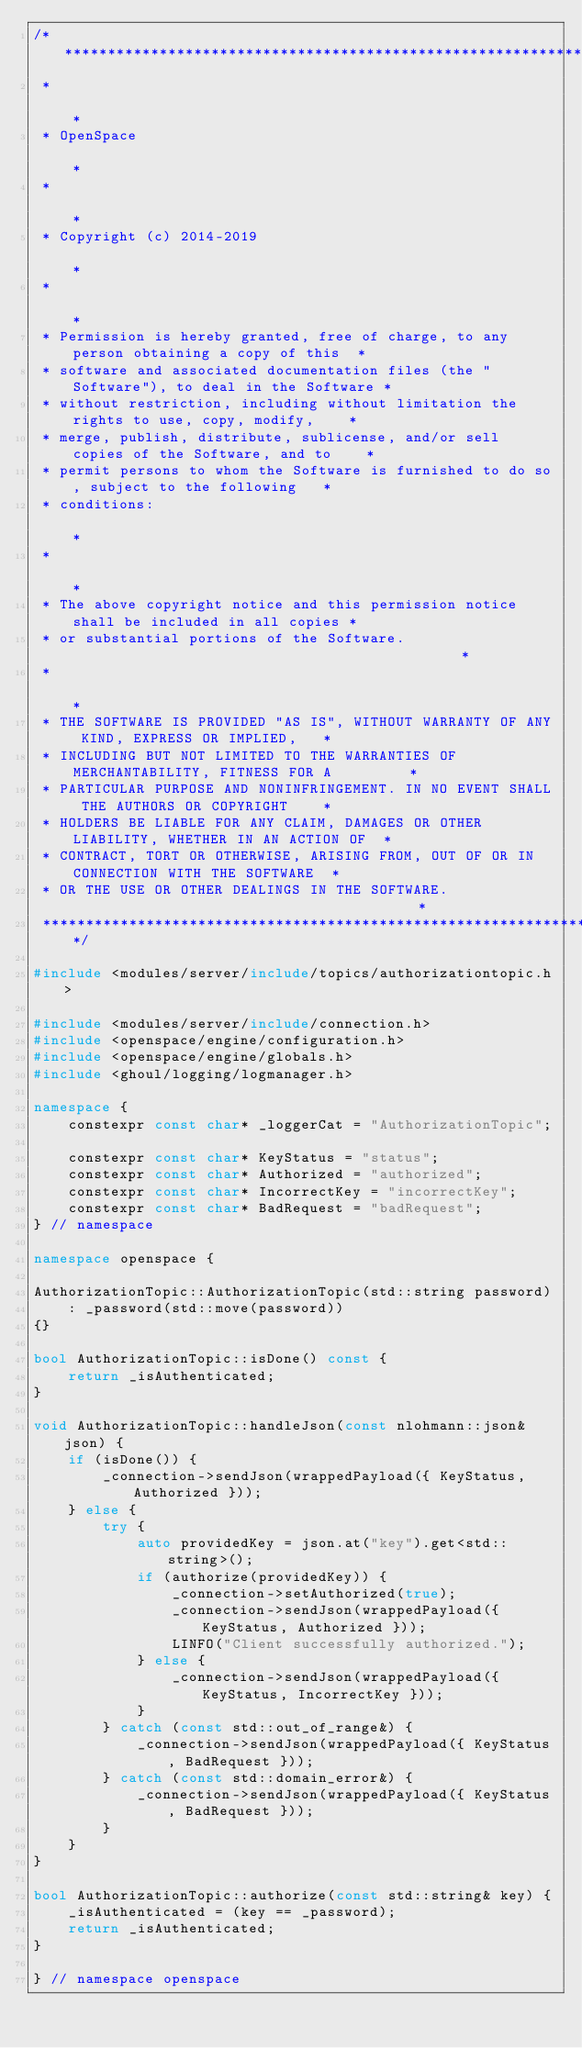Convert code to text. <code><loc_0><loc_0><loc_500><loc_500><_C++_>/*****************************************************************************************
 *                                                                                       *
 * OpenSpace                                                                             *
 *                                                                                       *
 * Copyright (c) 2014-2019                                                               *
 *                                                                                       *
 * Permission is hereby granted, free of charge, to any person obtaining a copy of this  *
 * software and associated documentation files (the "Software"), to deal in the Software *
 * without restriction, including without limitation the rights to use, copy, modify,    *
 * merge, publish, distribute, sublicense, and/or sell copies of the Software, and to    *
 * permit persons to whom the Software is furnished to do so, subject to the following   *
 * conditions:                                                                           *
 *                                                                                       *
 * The above copyright notice and this permission notice shall be included in all copies *
 * or substantial portions of the Software.                                              *
 *                                                                                       *
 * THE SOFTWARE IS PROVIDED "AS IS", WITHOUT WARRANTY OF ANY KIND, EXPRESS OR IMPLIED,   *
 * INCLUDING BUT NOT LIMITED TO THE WARRANTIES OF MERCHANTABILITY, FITNESS FOR A         *
 * PARTICULAR PURPOSE AND NONINFRINGEMENT. IN NO EVENT SHALL THE AUTHORS OR COPYRIGHT    *
 * HOLDERS BE LIABLE FOR ANY CLAIM, DAMAGES OR OTHER LIABILITY, WHETHER IN AN ACTION OF  *
 * CONTRACT, TORT OR OTHERWISE, ARISING FROM, OUT OF OR IN CONNECTION WITH THE SOFTWARE  *
 * OR THE USE OR OTHER DEALINGS IN THE SOFTWARE.                                         *
 ****************************************************************************************/

#include <modules/server/include/topics/authorizationtopic.h>

#include <modules/server/include/connection.h>
#include <openspace/engine/configuration.h>
#include <openspace/engine/globals.h>
#include <ghoul/logging/logmanager.h>

namespace {
    constexpr const char* _loggerCat = "AuthorizationTopic";

    constexpr const char* KeyStatus = "status";
    constexpr const char* Authorized = "authorized";
    constexpr const char* IncorrectKey = "incorrectKey";
    constexpr const char* BadRequest = "badRequest";
} // namespace

namespace openspace {

AuthorizationTopic::AuthorizationTopic(std::string password) 
    : _password(std::move(password))
{}

bool AuthorizationTopic::isDone() const {
    return _isAuthenticated;
}

void AuthorizationTopic::handleJson(const nlohmann::json& json) {
    if (isDone()) {
        _connection->sendJson(wrappedPayload({ KeyStatus, Authorized }));
    } else {
        try {
            auto providedKey = json.at("key").get<std::string>();
            if (authorize(providedKey)) {
                _connection->setAuthorized(true);
                _connection->sendJson(wrappedPayload({ KeyStatus, Authorized }));
                LINFO("Client successfully authorized.");
            } else {
                _connection->sendJson(wrappedPayload({ KeyStatus, IncorrectKey }));
            }
        } catch (const std::out_of_range&) {
            _connection->sendJson(wrappedPayload({ KeyStatus, BadRequest }));
        } catch (const std::domain_error&) {
            _connection->sendJson(wrappedPayload({ KeyStatus, BadRequest }));
        }
    }
}

bool AuthorizationTopic::authorize(const std::string& key) {
    _isAuthenticated = (key == _password);
    return _isAuthenticated;
}

} // namespace openspace
</code> 